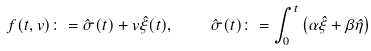Convert formula to latex. <formula><loc_0><loc_0><loc_500><loc_500>f ( t , v ) \colon = \hat { \sigma } ( t ) + v \hat { \xi } ( t ) , \quad \hat { \sigma } ( t ) \colon = \int _ { 0 } ^ { t } \left ( \alpha \hat { \xi } + \beta \hat { \eta } \right )</formula> 